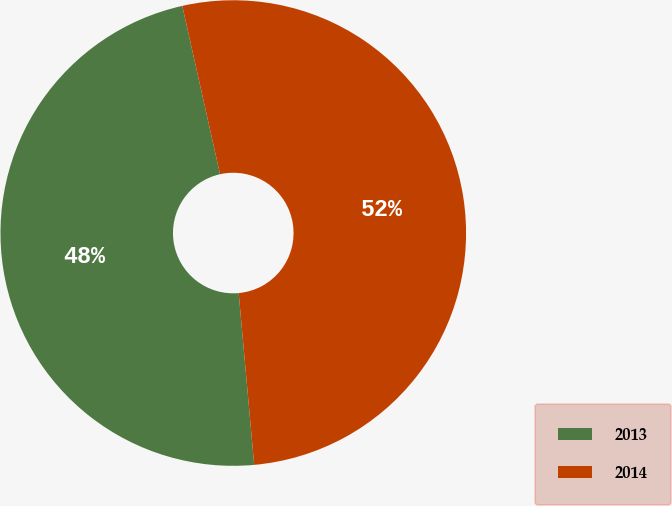Convert chart to OTSL. <chart><loc_0><loc_0><loc_500><loc_500><pie_chart><fcel>2013<fcel>2014<nl><fcel>47.92%<fcel>52.08%<nl></chart> 